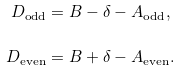Convert formula to latex. <formula><loc_0><loc_0><loc_500><loc_500>D _ { \text {odd} } & = B - \delta - A _ { \text {odd} } , \\ D _ { \text {even} } & = B + \delta - A _ { \text {even} } .</formula> 